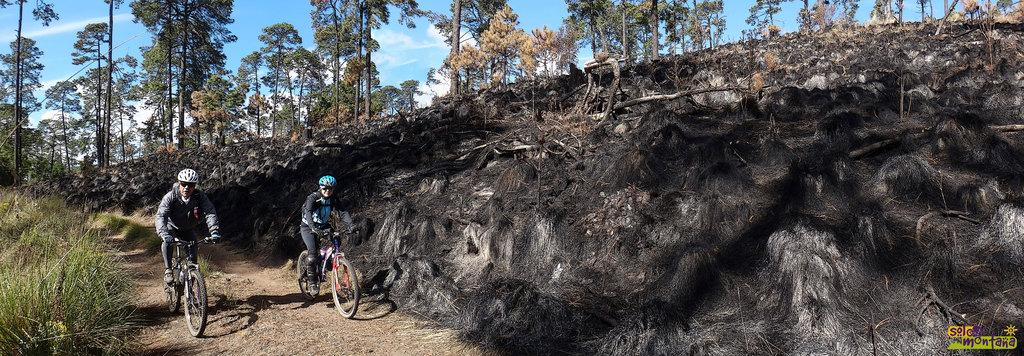How many people are in the foreground of the image? There are two persons in the foreground of the image. What are the two persons doing in the image? The two persons are riding a bicycle. What is the position of the bicycle in the image? The bicycle is on the ground. What can be seen in the background of the image? Mountains, grass, trees, and the sky are visible in the background of the image. When was the image taken? The image was taken during the day. What type of laborer is working on the construction site in the image? There is no construction site or laborer present in the image. Can you tell me how many baths are visible in the image? There are no baths present in the image. 